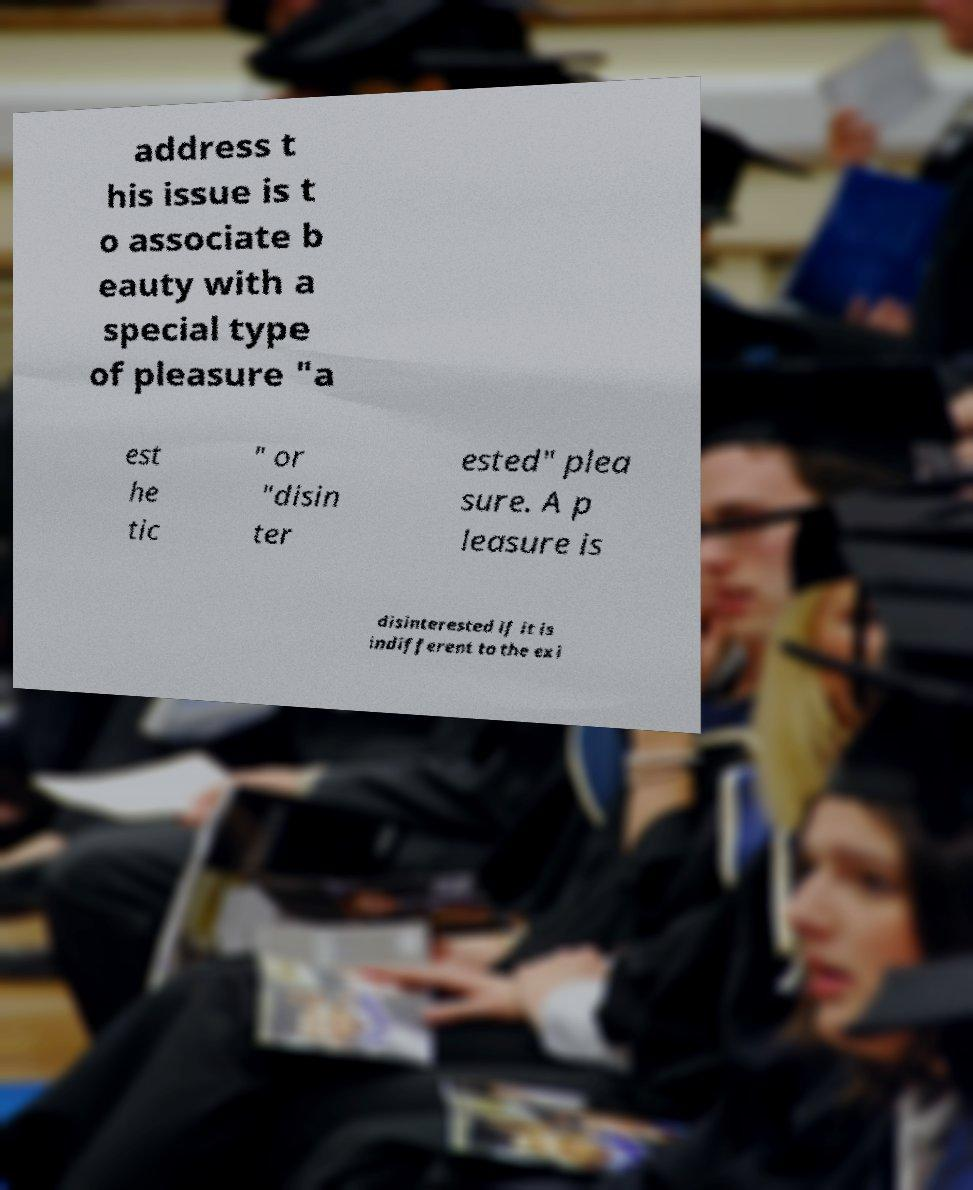Can you accurately transcribe the text from the provided image for me? address t his issue is t o associate b eauty with a special type of pleasure "a est he tic " or "disin ter ested" plea sure. A p leasure is disinterested if it is indifferent to the exi 